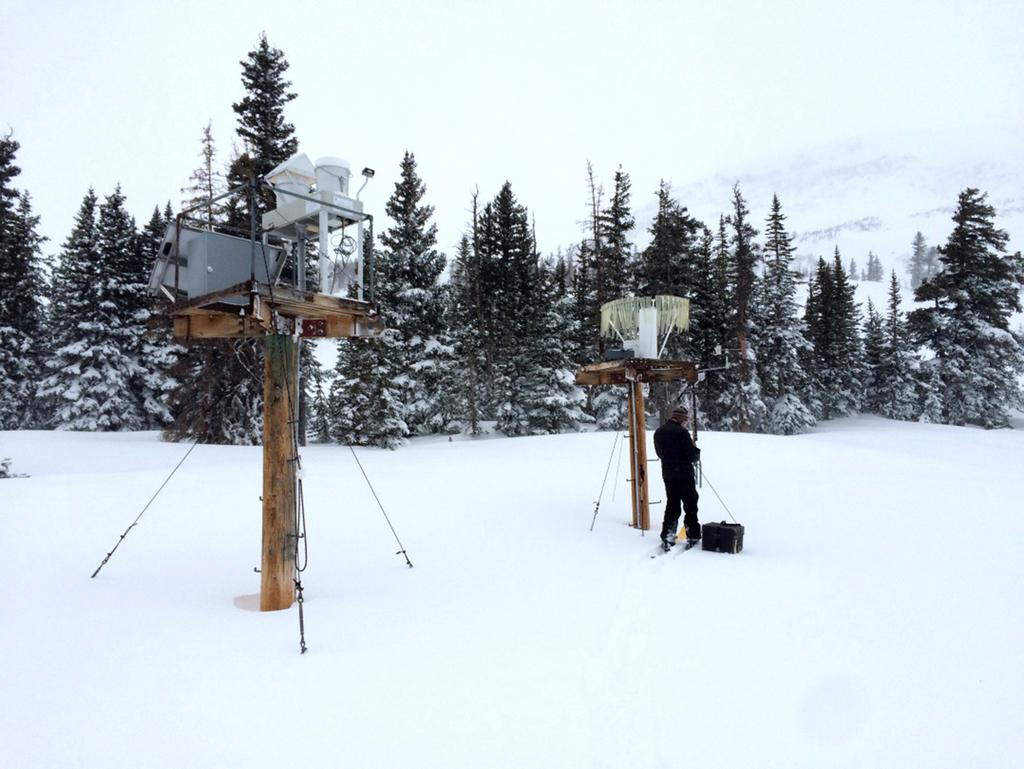What is the person in the image standing on? The person is standing on the snow. What object is beside the person? There is a box beside the person. What can be seen on the left side of the image? There are 2 wooden stands on the left side of the image. What is visible in the background of the image? There are trees visible in the background of the image. What design is on the desk in the image? There is no desk present in the image. 